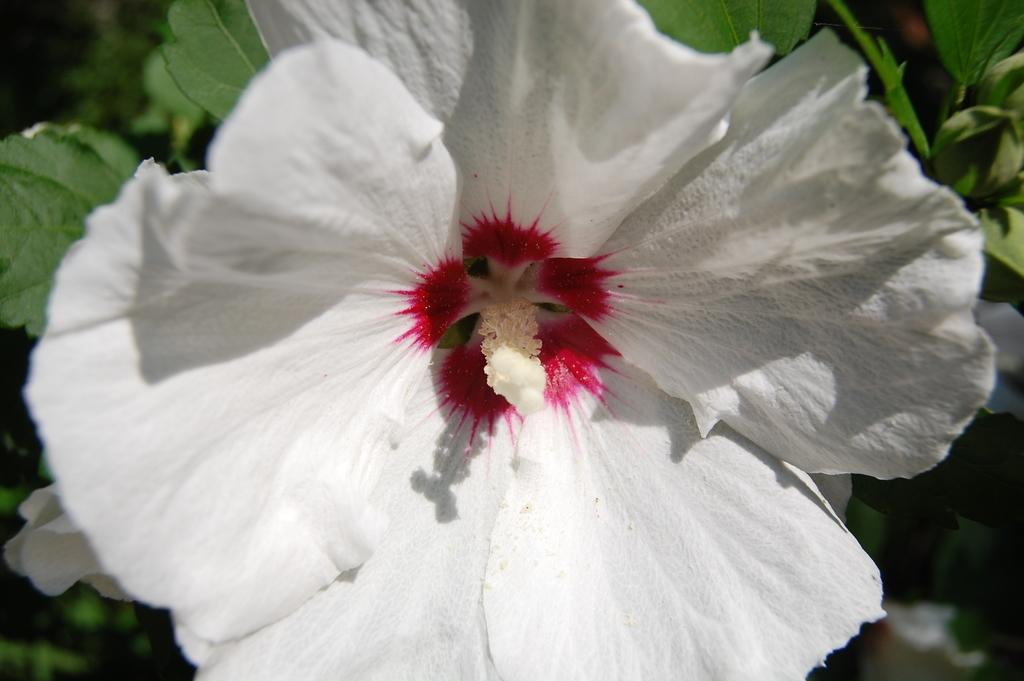What is the main subject of the picture? The main subject of the picture is a flower. What else can be seen in the picture besides the flower? There are leaves in the picture. How would you describe the background of the image? The background of the image is blurred. Can you tell me how many dogs are visible in the picture? There are no dogs present in the picture; it features a flower and leaves. What type of earth is shown in the picture? There is no earth visible in the picture; it is a close-up of a flower and leaves. 